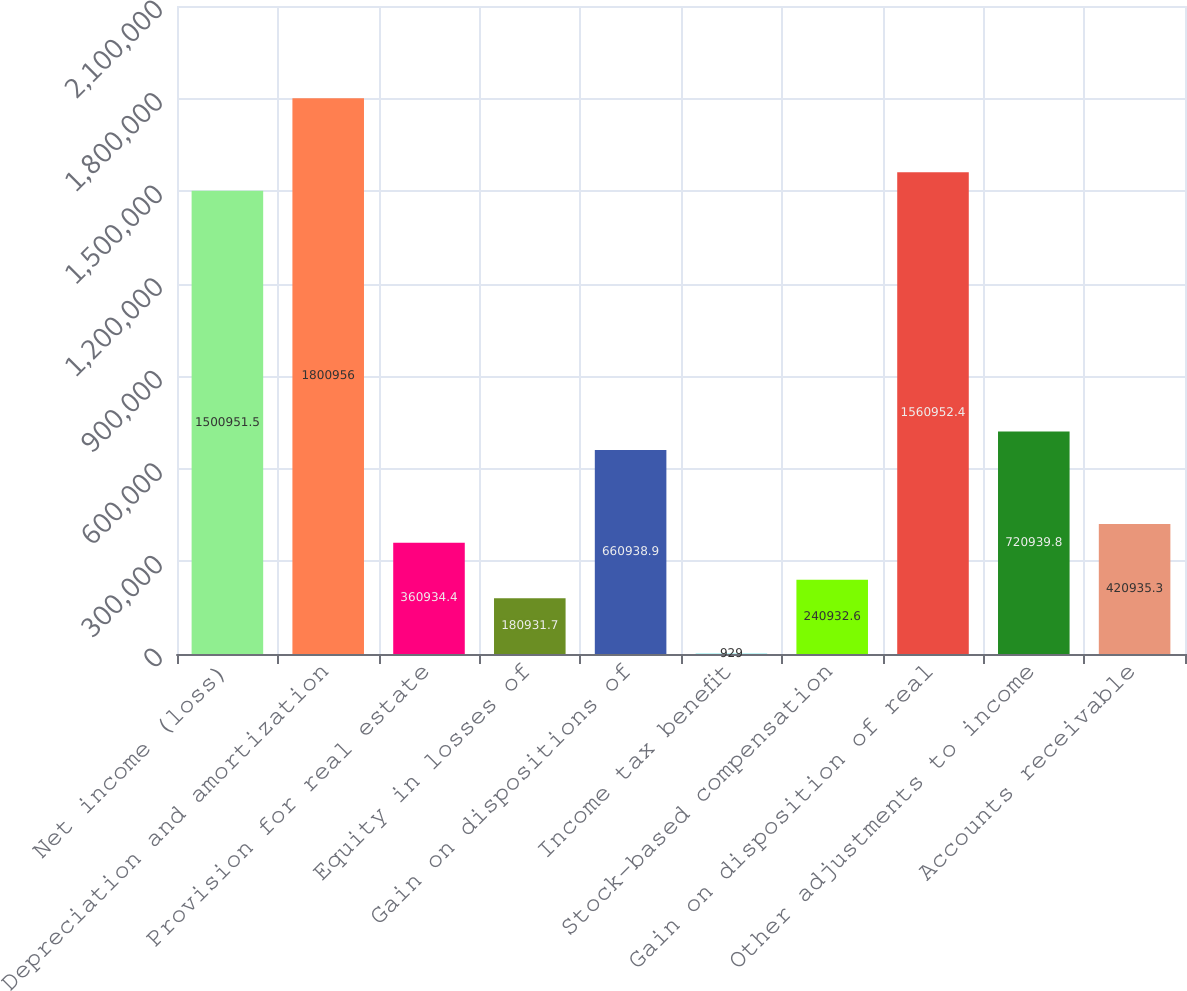Convert chart. <chart><loc_0><loc_0><loc_500><loc_500><bar_chart><fcel>Net income (loss)<fcel>Depreciation and amortization<fcel>Provision for real estate<fcel>Equity in losses of<fcel>Gain on dispositions of<fcel>Income tax benefit<fcel>Stock-based compensation<fcel>Gain on disposition of real<fcel>Other adjustments to income<fcel>Accounts receivable<nl><fcel>1.50095e+06<fcel>1.80096e+06<fcel>360934<fcel>180932<fcel>660939<fcel>929<fcel>240933<fcel>1.56095e+06<fcel>720940<fcel>420935<nl></chart> 